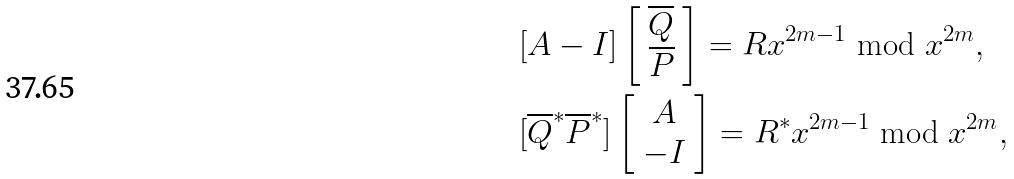<formula> <loc_0><loc_0><loc_500><loc_500>& [ A - I ] \left [ \begin{array} { c } \overline { Q } \\ \overline { P } \end{array} \right ] = R x ^ { 2 m - 1 } \bmod x ^ { 2 m } , \\ & [ \overline { Q } ^ { * } \overline { P } ^ { * } ] \left [ \begin{array} { c } A \\ - I \end{array} \right ] = R ^ { * } x ^ { 2 m - 1 } \bmod x ^ { 2 m } ,</formula> 